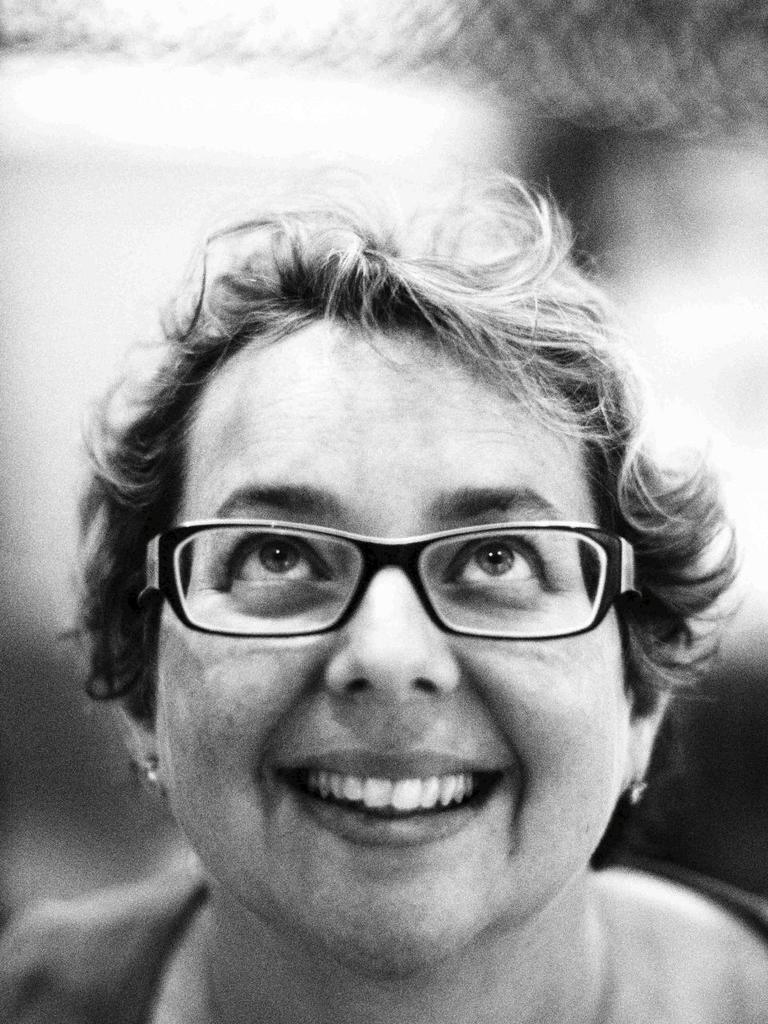Who is present in the image? There is a woman in the image. What accessory is the woman wearing? The woman is wearing glasses. What type of rail can be seen in the image? There is no rail present in the image; it only features a woman wearing glasses. 